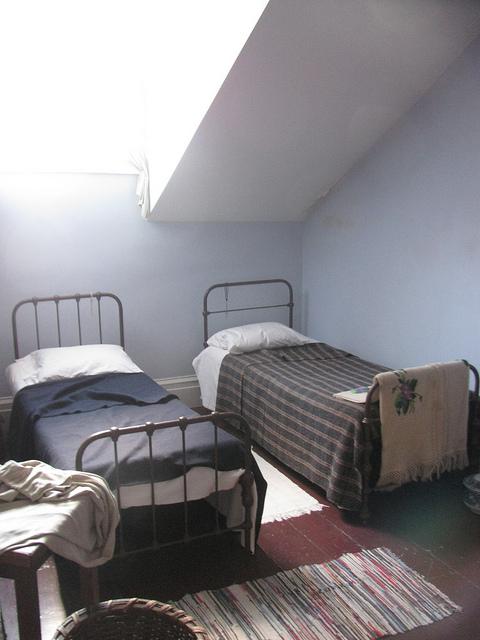Is the room dark?
Quick response, please. No. What color are the walls?
Concise answer only. White. Are these mattresses for sale?
Keep it brief. No. How many beds are in the photo?
Give a very brief answer. 2. Do these beds have blankets?
Answer briefly. Yes. Is that a new sheet?
Write a very short answer. No. What color is the bedspread on the bed?
Give a very brief answer. Blue. How many beds are there?
Concise answer only. 2. Does these bed look identical?
Short answer required. No. 